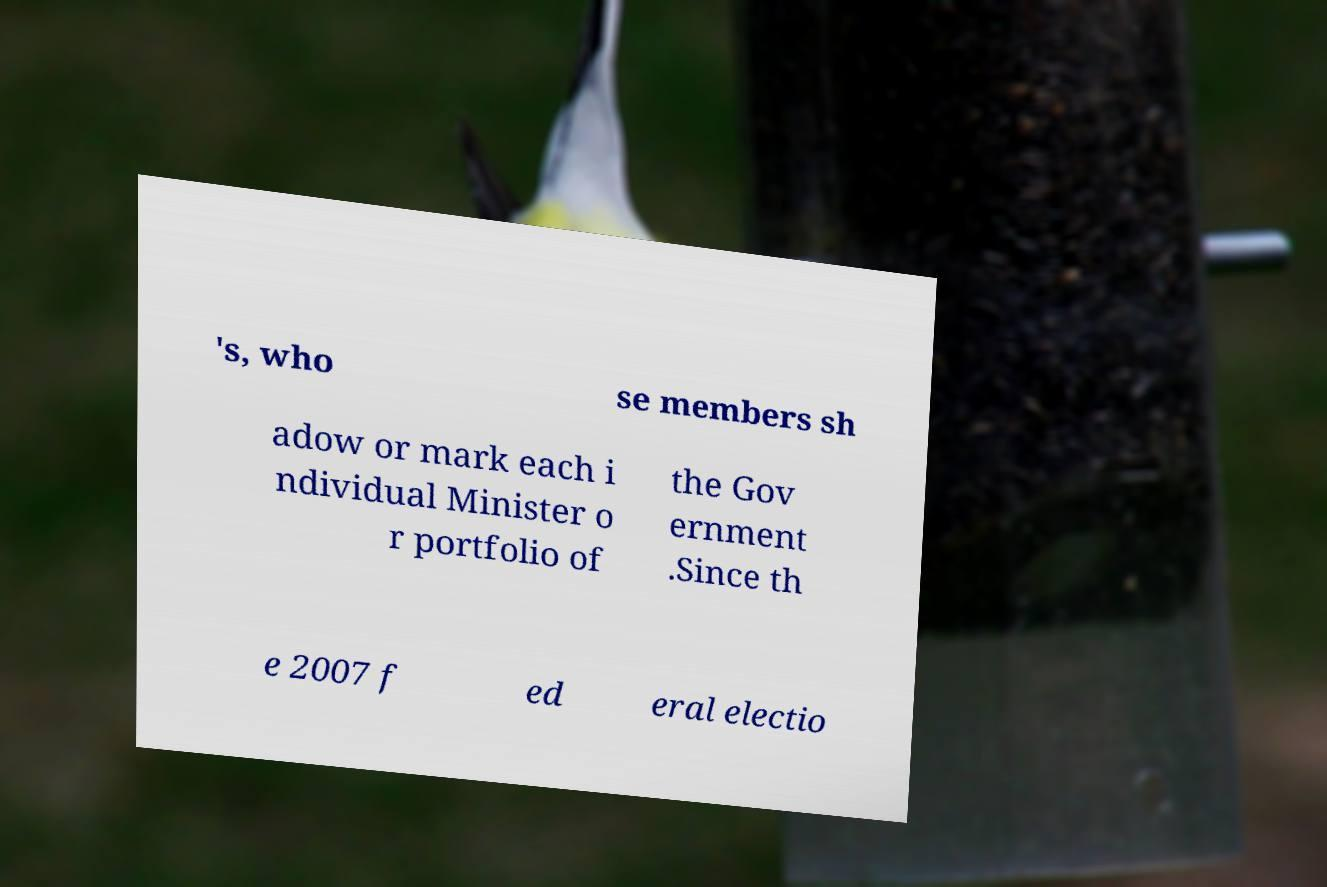Can you accurately transcribe the text from the provided image for me? 's, who se members sh adow or mark each i ndividual Minister o r portfolio of the Gov ernment .Since th e 2007 f ed eral electio 